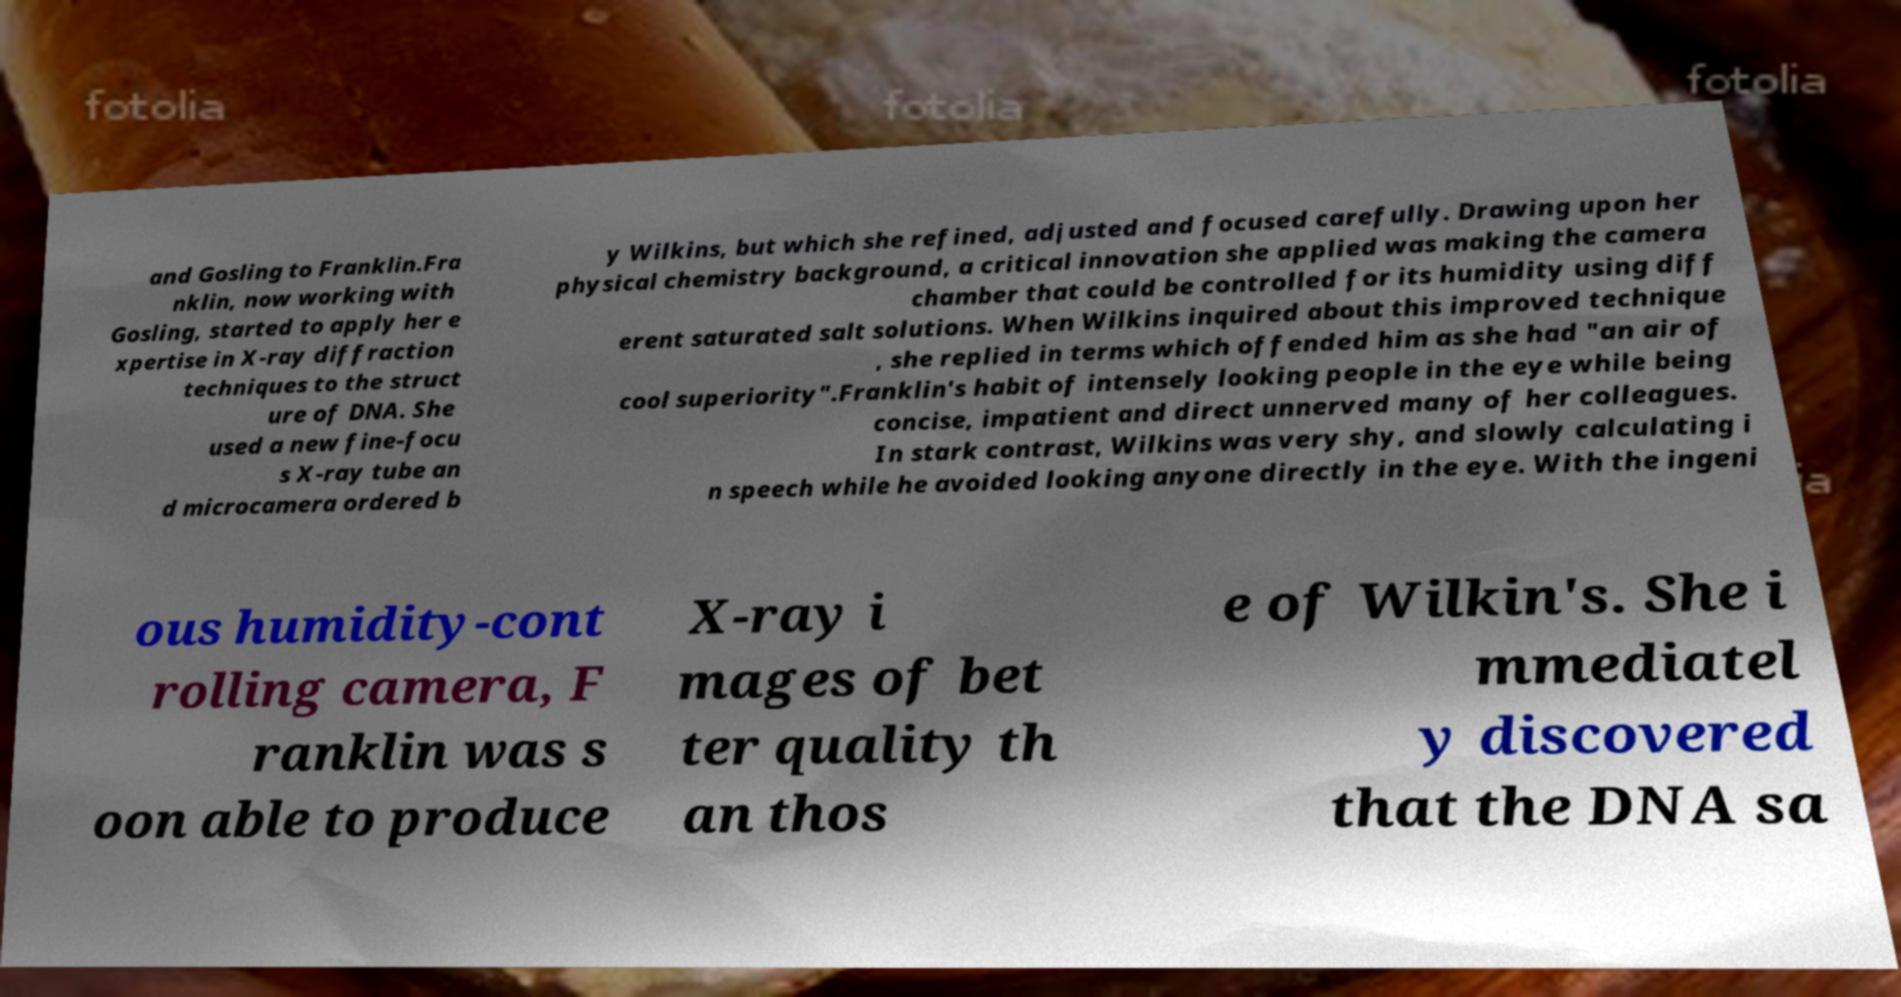Please read and relay the text visible in this image. What does it say? and Gosling to Franklin.Fra nklin, now working with Gosling, started to apply her e xpertise in X-ray diffraction techniques to the struct ure of DNA. She used a new fine-focu s X-ray tube an d microcamera ordered b y Wilkins, but which she refined, adjusted and focused carefully. Drawing upon her physical chemistry background, a critical innovation she applied was making the camera chamber that could be controlled for its humidity using diff erent saturated salt solutions. When Wilkins inquired about this improved technique , she replied in terms which offended him as she had "an air of cool superiority".Franklin's habit of intensely looking people in the eye while being concise, impatient and direct unnerved many of her colleagues. In stark contrast, Wilkins was very shy, and slowly calculating i n speech while he avoided looking anyone directly in the eye. With the ingeni ous humidity-cont rolling camera, F ranklin was s oon able to produce X-ray i mages of bet ter quality th an thos e of Wilkin's. She i mmediatel y discovered that the DNA sa 